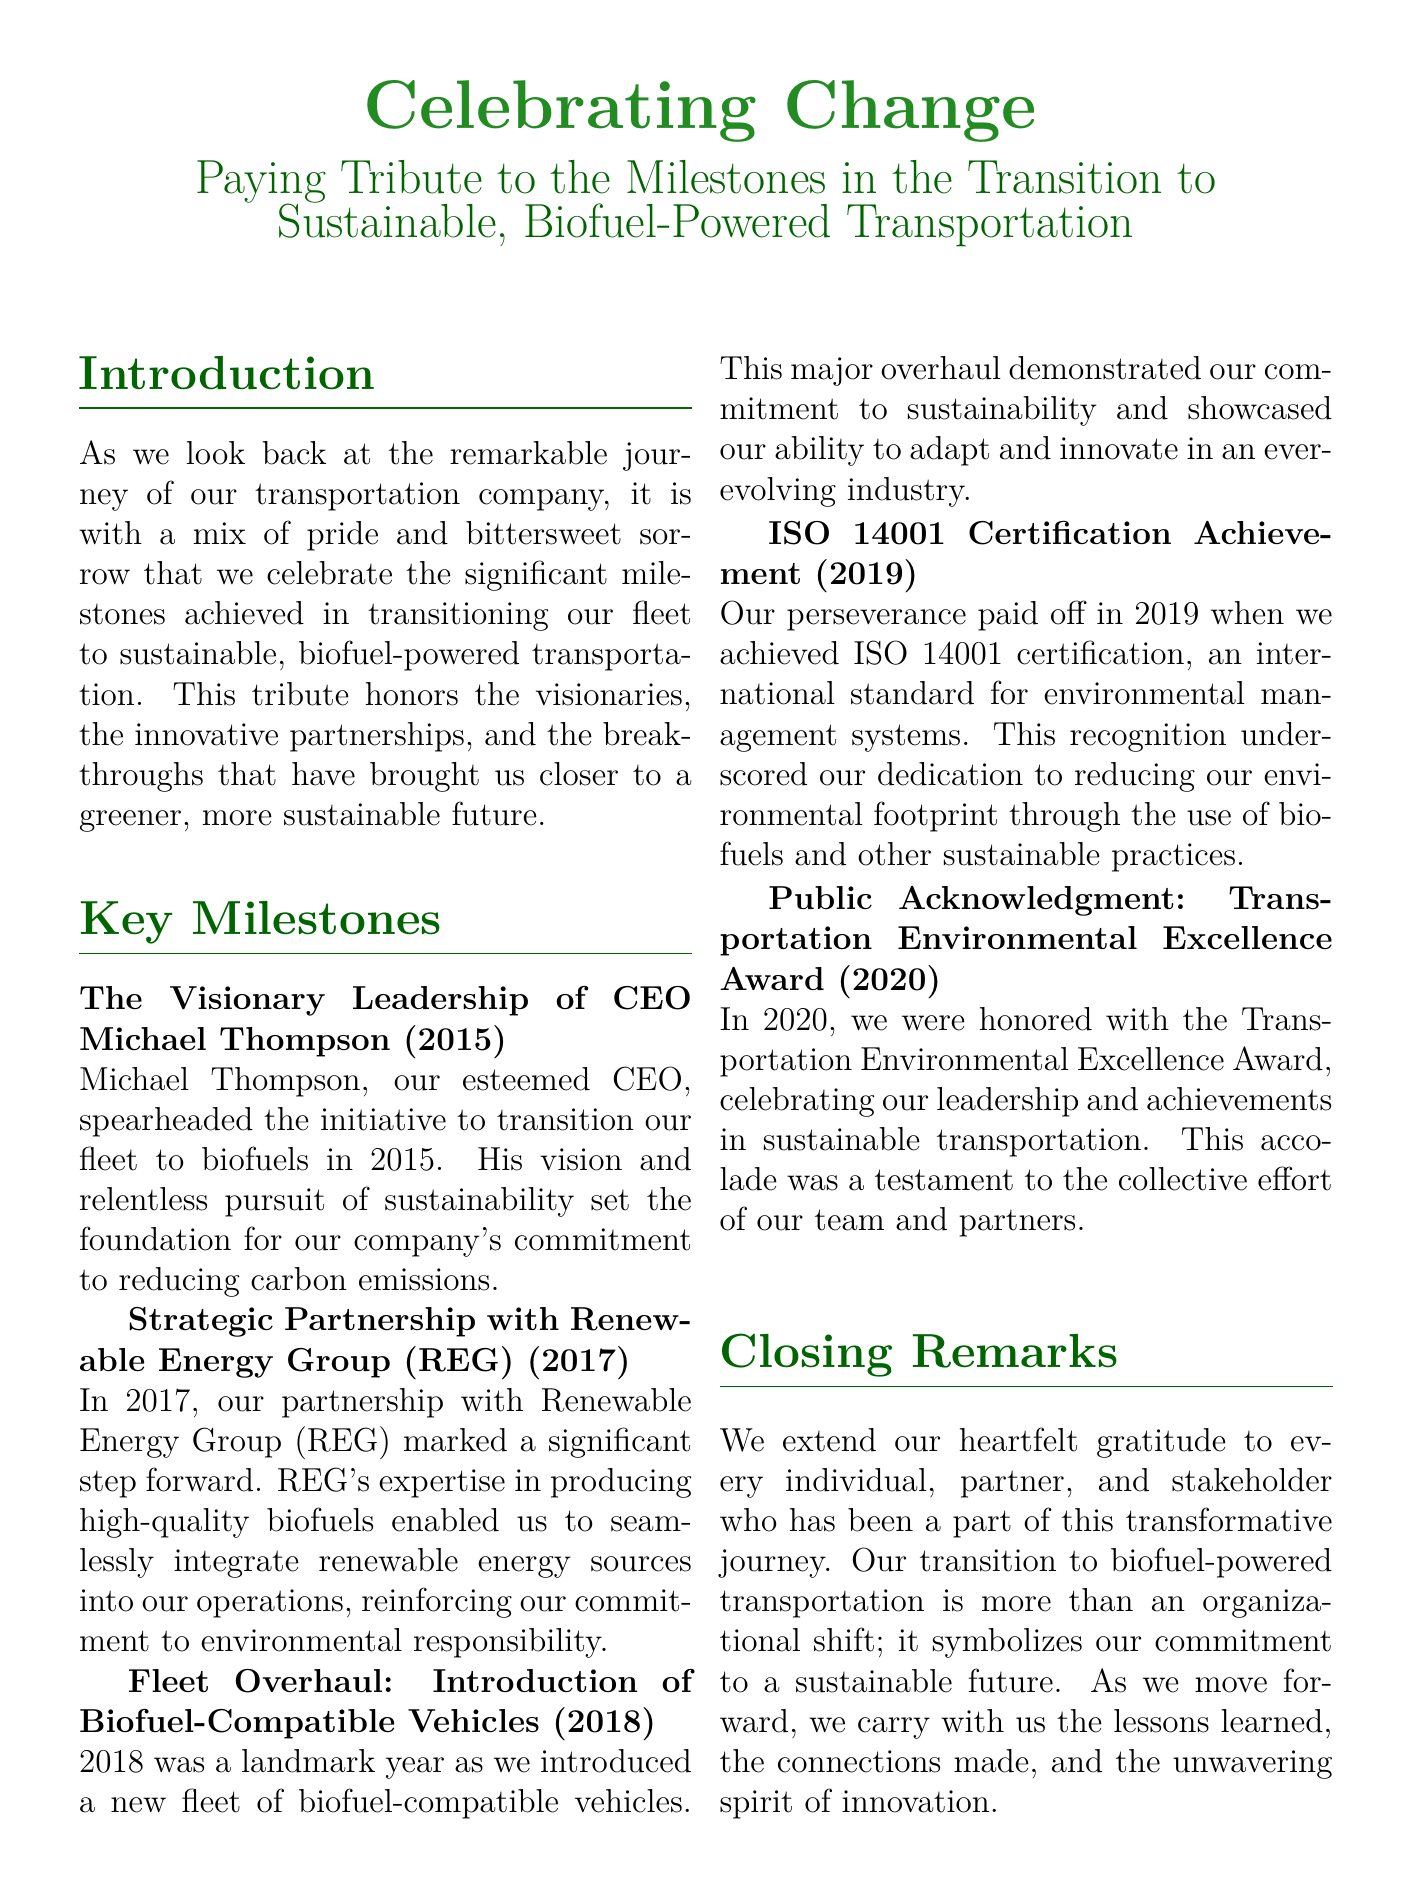what year did Michael Thompson spearhead the initiative? The document states that this milestone occurred in 2015.
Answer: 2015 what organization did the transportation company partner with in 2017? The document mentions the partnership with Renewable Energy Group (REG).
Answer: Renewable Energy Group (REG) what major vehicle introduction occurred in 2018? The document indicates the introduction of biofuel-compatible vehicles.
Answer: biofuel-compatible vehicles which certification was achieved in 2019? The document specifies that the ISO 14001 certification was achieved.
Answer: ISO 14001 certification what award did the company receive in 2020? The document states that they received the Transportation Environmental Excellence Award.
Answer: Transportation Environmental Excellence Award how many key milestones are listed in the document? The document outlines a total of five key milestones in the transition to biofuels.
Answer: five what does the transition symbolize for the company? According to the document, the transition symbolizes their commitment to a sustainable future.
Answer: commitment to a sustainable future who is recognized as a visionary leader in the document? The document highlights CEO Michael Thompson as the visionary leader.
Answer: Michael Thompson 